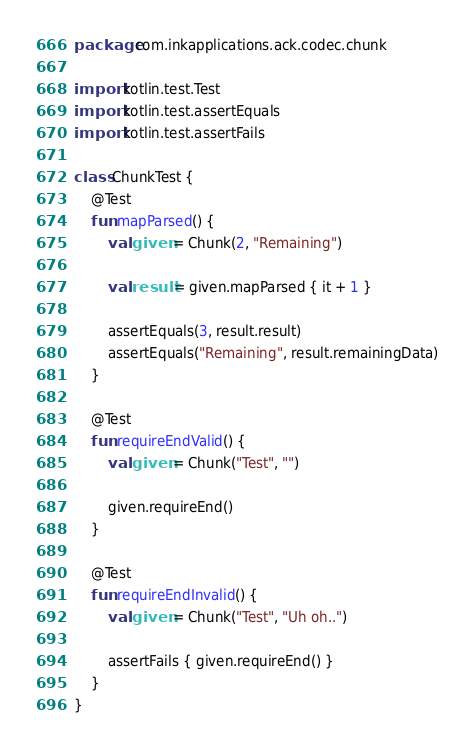<code> <loc_0><loc_0><loc_500><loc_500><_Kotlin_>package com.inkapplications.ack.codec.chunk

import kotlin.test.Test
import kotlin.test.assertEquals
import kotlin.test.assertFails

class ChunkTest {
    @Test
    fun mapParsed() {
        val given = Chunk(2, "Remaining")

        val result = given.mapParsed { it + 1 }

        assertEquals(3, result.result)
        assertEquals("Remaining", result.remainingData)
    }

    @Test
    fun requireEndValid() {
        val given = Chunk("Test", "")

        given.requireEnd()
    }

    @Test
    fun requireEndInvalid() {
        val given = Chunk("Test", "Uh oh..")

        assertFails { given.requireEnd() }
    }
}
</code> 